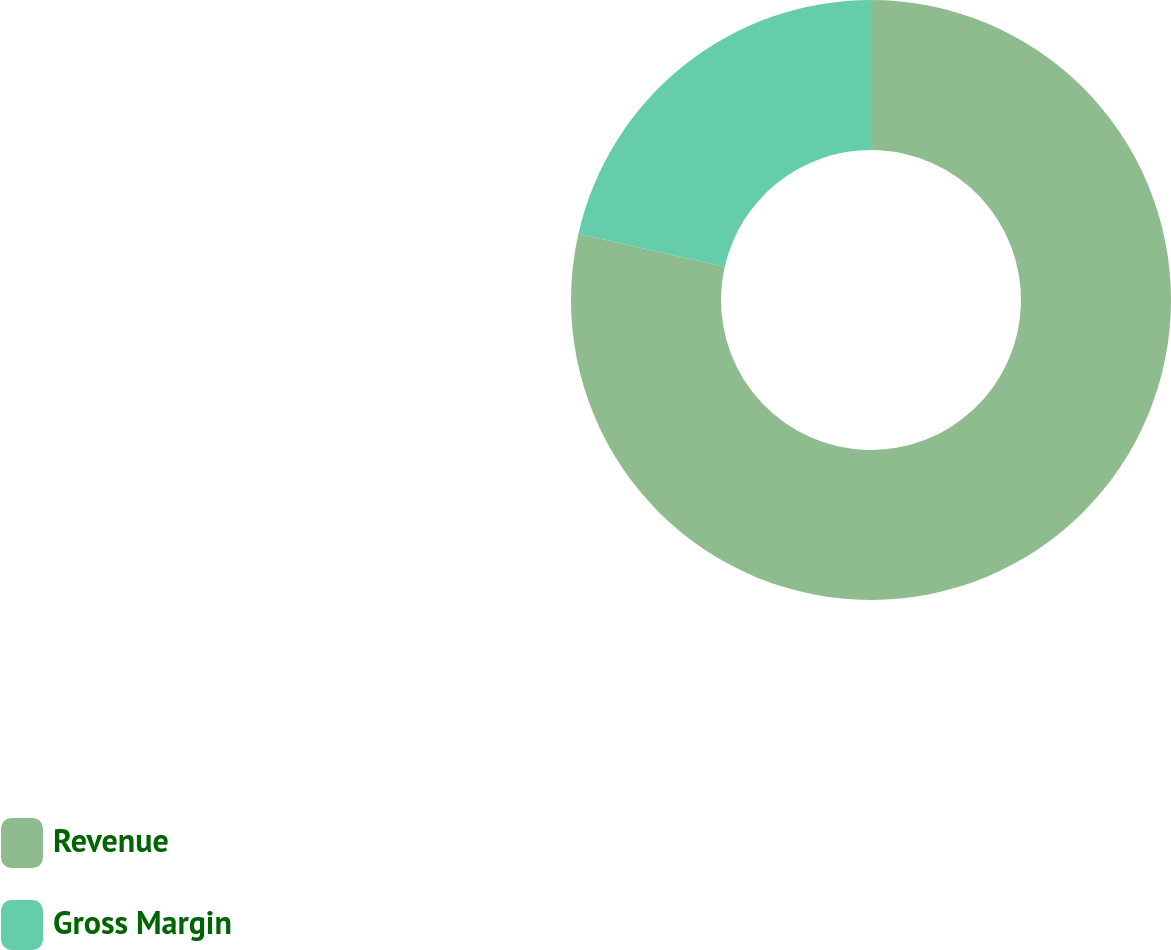<chart> <loc_0><loc_0><loc_500><loc_500><pie_chart><fcel>Revenue<fcel>Gross Margin<nl><fcel>78.55%<fcel>21.45%<nl></chart> 